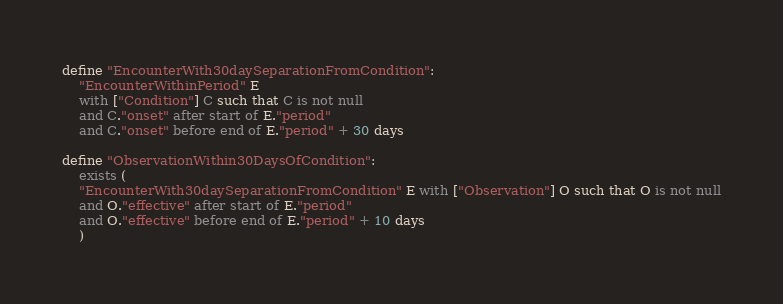<code> <loc_0><loc_0><loc_500><loc_500><_SQL_>define "EncounterWith30daySeparationFromCondition":
	"EncounterWithinPeriod" E
	with ["Condition"] C such that C is not null
	and C."onset" after start of E."period"
	and C."onset" before end of E."period" + 30 days

define "ObservationWithin30DaysOfCondition":
	exists (
	"EncounterWith30daySeparationFromCondition" E with ["Observation"] O such that O is not null
	and O."effective" after start of E."period"
	and O."effective" before end of E."period" + 10 days
	)</code> 